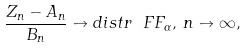Convert formula to latex. <formula><loc_0><loc_0><loc_500><loc_500>\frac { Z _ { n } - A _ { n } } { B _ { n } } \to d i s t r \ F F _ { \alpha } , \, n \to \infty ,</formula> 